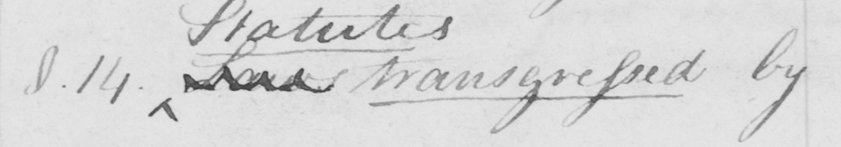Please transcribe the handwritten text in this image. §.14 . Laws transgressed by 